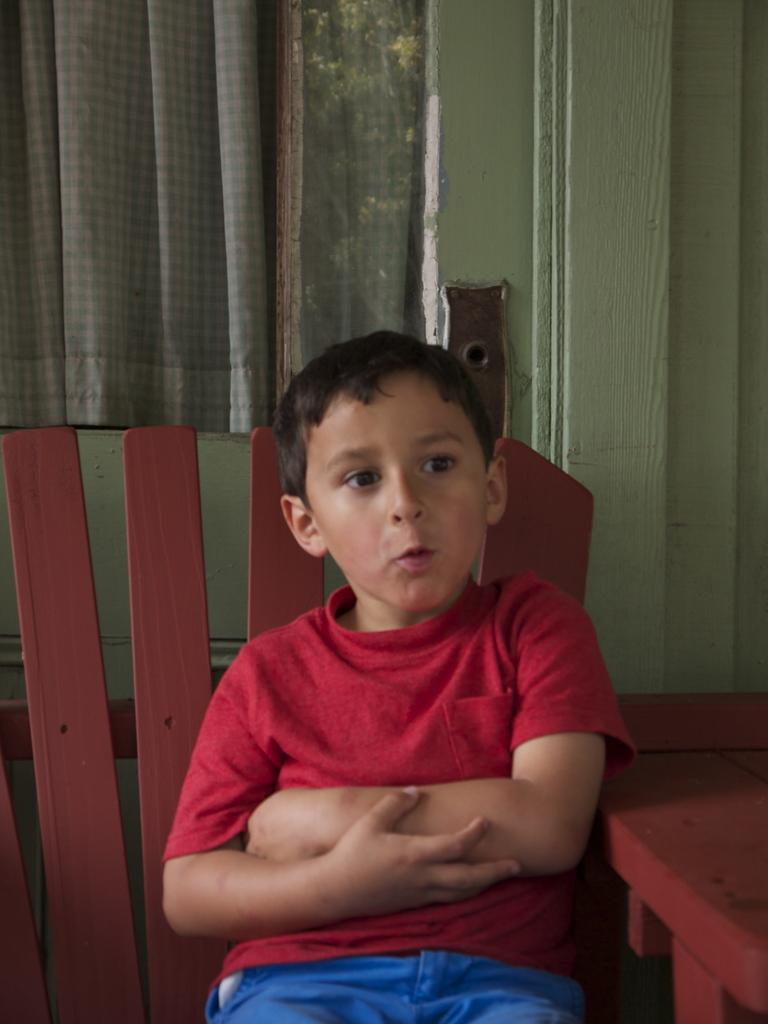Where was the image taken? The image was taken inside a room. What is the boy in the image doing? The boy is sitting on a chair. What is the boy wearing? The boy is wearing a red t-shirt and blue pants. What colors can be seen on the walls and curtains in the background? There is a green color wall and a grey color curtain in the background. What type of bread is the boy holding in the image? There is no bread present in the image. Is there a woman in the image adjusting the curtain? There is no woman present in the image, and the curtain is not being adjusted. 